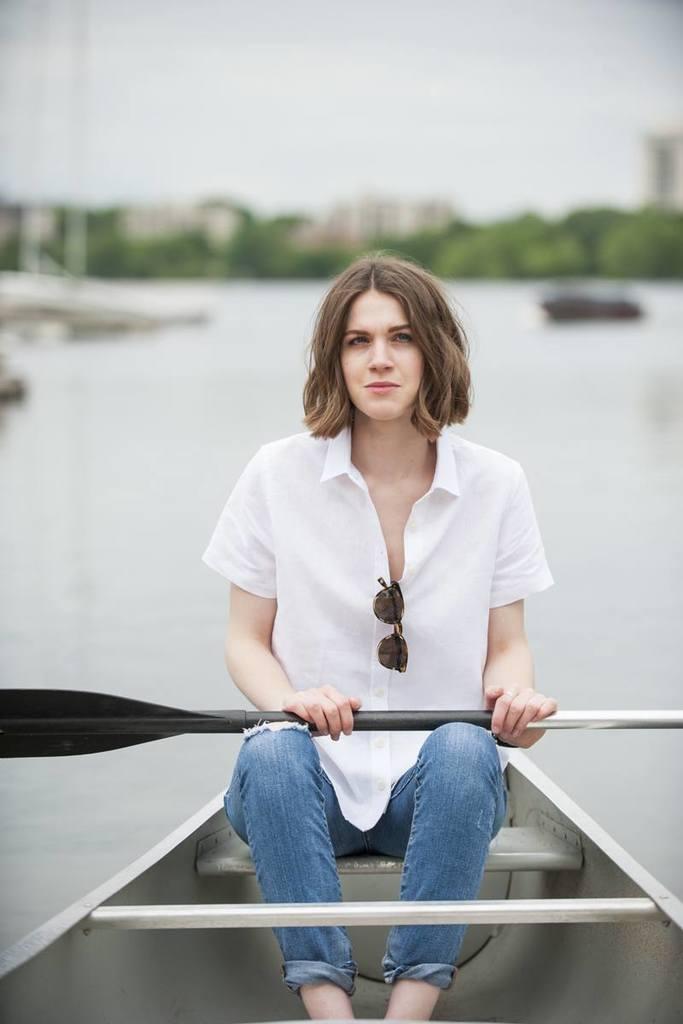Please provide a concise description of this image. In the picture we can see a woman sitting on the boat and holding a stick to ride it and she is in the white shirt and goggles to it and in the background, we can see water and far from it we can see some trees, buildings and sky 